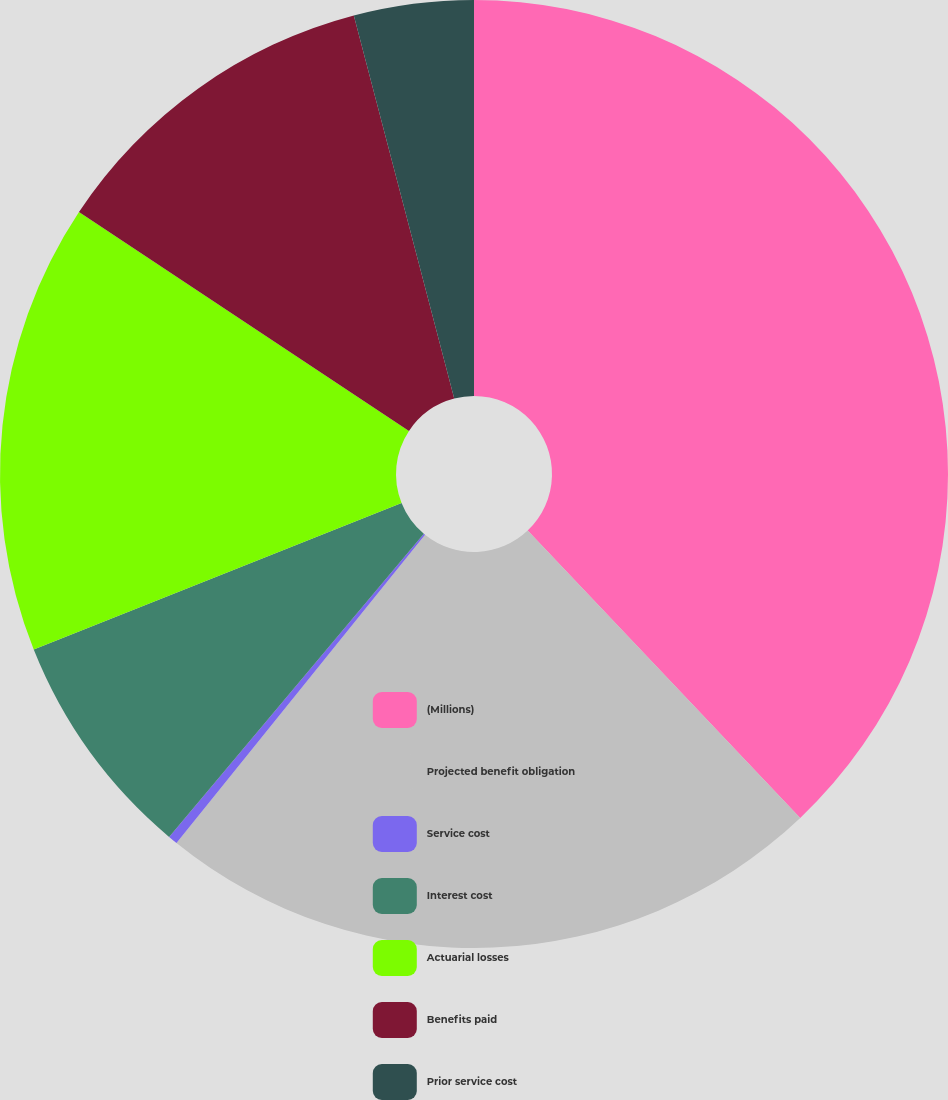Convert chart to OTSL. <chart><loc_0><loc_0><loc_500><loc_500><pie_chart><fcel>(Millions)<fcel>Projected benefit obligation<fcel>Service cost<fcel>Interest cost<fcel>Actuarial losses<fcel>Benefits paid<fcel>Prior service cost<nl><fcel>37.92%<fcel>22.88%<fcel>0.32%<fcel>7.84%<fcel>15.36%<fcel>11.6%<fcel>4.08%<nl></chart> 